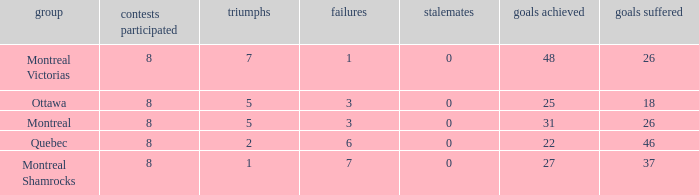For teams with more than 0 ties and goals against of 37, how many wins were tallied? None. Can you parse all the data within this table? {'header': ['group', 'contests participated', 'triumphs', 'failures', 'stalemates', 'goals achieved', 'goals suffered'], 'rows': [['Montreal Victorias', '8', '7', '1', '0', '48', '26'], ['Ottawa', '8', '5', '3', '0', '25', '18'], ['Montreal', '8', '5', '3', '0', '31', '26'], ['Quebec', '8', '2', '6', '0', '22', '46'], ['Montreal Shamrocks', '8', '1', '7', '0', '27', '37']]} 